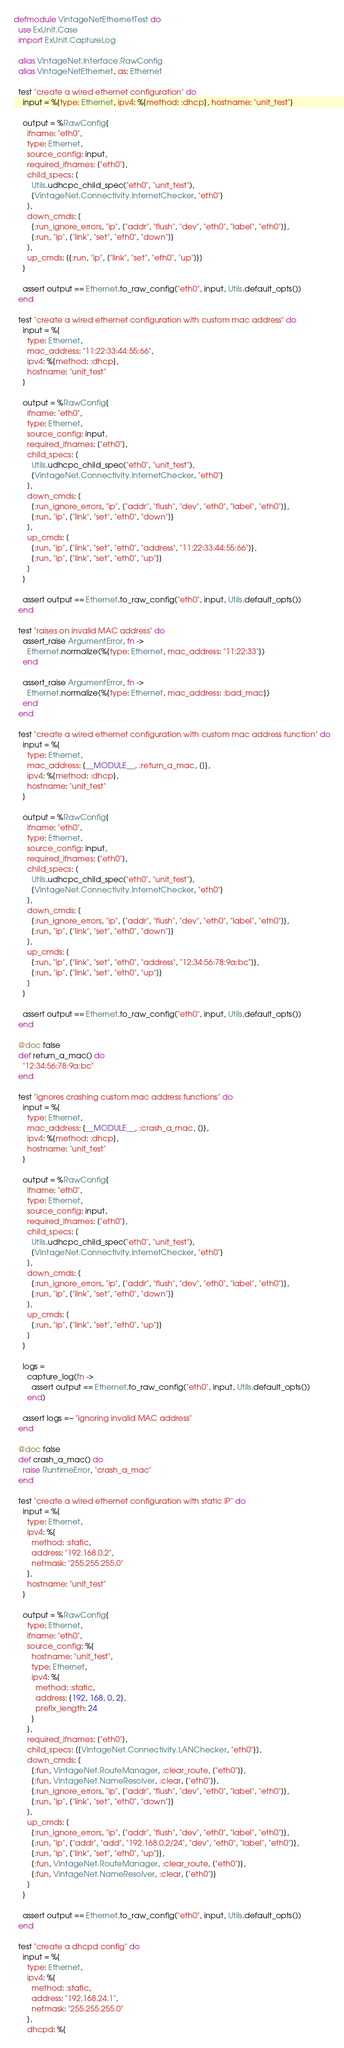<code> <loc_0><loc_0><loc_500><loc_500><_Elixir_>defmodule VintageNetEthernetTest do
  use ExUnit.Case
  import ExUnit.CaptureLog

  alias VintageNet.Interface.RawConfig
  alias VintageNetEthernet, as: Ethernet

  test "create a wired ethernet configuration" do
    input = %{type: Ethernet, ipv4: %{method: :dhcp}, hostname: "unit_test"}

    output = %RawConfig{
      ifname: "eth0",
      type: Ethernet,
      source_config: input,
      required_ifnames: ["eth0"],
      child_specs: [
        Utils.udhcpc_child_spec("eth0", "unit_test"),
        {VintageNet.Connectivity.InternetChecker, "eth0"}
      ],
      down_cmds: [
        {:run_ignore_errors, "ip", ["addr", "flush", "dev", "eth0", "label", "eth0"]},
        {:run, "ip", ["link", "set", "eth0", "down"]}
      ],
      up_cmds: [{:run, "ip", ["link", "set", "eth0", "up"]}]
    }

    assert output == Ethernet.to_raw_config("eth0", input, Utils.default_opts())
  end

  test "create a wired ethernet configuration with custom mac address" do
    input = %{
      type: Ethernet,
      mac_address: "11:22:33:44:55:66",
      ipv4: %{method: :dhcp},
      hostname: "unit_test"
    }

    output = %RawConfig{
      ifname: "eth0",
      type: Ethernet,
      source_config: input,
      required_ifnames: ["eth0"],
      child_specs: [
        Utils.udhcpc_child_spec("eth0", "unit_test"),
        {VintageNet.Connectivity.InternetChecker, "eth0"}
      ],
      down_cmds: [
        {:run_ignore_errors, "ip", ["addr", "flush", "dev", "eth0", "label", "eth0"]},
        {:run, "ip", ["link", "set", "eth0", "down"]}
      ],
      up_cmds: [
        {:run, "ip", ["link", "set", "eth0", "address", "11:22:33:44:55:66"]},
        {:run, "ip", ["link", "set", "eth0", "up"]}
      ]
    }

    assert output == Ethernet.to_raw_config("eth0", input, Utils.default_opts())
  end

  test "raises on invalid MAC address" do
    assert_raise ArgumentError, fn ->
      Ethernet.normalize(%{type: Ethernet, mac_address: "11:22:33"})
    end

    assert_raise ArgumentError, fn ->
      Ethernet.normalize(%{type: Ethernet, mac_address: :bad_mac})
    end
  end

  test "create a wired ethernet configuration with custom mac address function" do
    input = %{
      type: Ethernet,
      mac_address: {__MODULE__, :return_a_mac, []},
      ipv4: %{method: :dhcp},
      hostname: "unit_test"
    }

    output = %RawConfig{
      ifname: "eth0",
      type: Ethernet,
      source_config: input,
      required_ifnames: ["eth0"],
      child_specs: [
        Utils.udhcpc_child_spec("eth0", "unit_test"),
        {VintageNet.Connectivity.InternetChecker, "eth0"}
      ],
      down_cmds: [
        {:run_ignore_errors, "ip", ["addr", "flush", "dev", "eth0", "label", "eth0"]},
        {:run, "ip", ["link", "set", "eth0", "down"]}
      ],
      up_cmds: [
        {:run, "ip", ["link", "set", "eth0", "address", "12:34:56:78:9a:bc"]},
        {:run, "ip", ["link", "set", "eth0", "up"]}
      ]
    }

    assert output == Ethernet.to_raw_config("eth0", input, Utils.default_opts())
  end

  @doc false
  def return_a_mac() do
    "12:34:56:78:9a:bc"
  end

  test "ignores crashing custom mac address functions" do
    input = %{
      type: Ethernet,
      mac_address: {__MODULE__, :crash_a_mac, []},
      ipv4: %{method: :dhcp},
      hostname: "unit_test"
    }

    output = %RawConfig{
      ifname: "eth0",
      type: Ethernet,
      source_config: input,
      required_ifnames: ["eth0"],
      child_specs: [
        Utils.udhcpc_child_spec("eth0", "unit_test"),
        {VintageNet.Connectivity.InternetChecker, "eth0"}
      ],
      down_cmds: [
        {:run_ignore_errors, "ip", ["addr", "flush", "dev", "eth0", "label", "eth0"]},
        {:run, "ip", ["link", "set", "eth0", "down"]}
      ],
      up_cmds: [
        {:run, "ip", ["link", "set", "eth0", "up"]}
      ]
    }

    logs =
      capture_log(fn ->
        assert output == Ethernet.to_raw_config("eth0", input, Utils.default_opts())
      end)

    assert logs =~ "ignoring invalid MAC address"
  end

  @doc false
  def crash_a_mac() do
    raise RuntimeError, "crash_a_mac"
  end

  test "create a wired ethernet configuration with static IP" do
    input = %{
      type: Ethernet,
      ipv4: %{
        method: :static,
        address: "192.168.0.2",
        netmask: "255.255.255.0"
      },
      hostname: "unit_test"
    }

    output = %RawConfig{
      type: Ethernet,
      ifname: "eth0",
      source_config: %{
        hostname: "unit_test",
        type: Ethernet,
        ipv4: %{
          method: :static,
          address: {192, 168, 0, 2},
          prefix_length: 24
        }
      },
      required_ifnames: ["eth0"],
      child_specs: [{VintageNet.Connectivity.LANChecker, "eth0"}],
      down_cmds: [
        {:fun, VintageNet.RouteManager, :clear_route, ["eth0"]},
        {:fun, VintageNet.NameResolver, :clear, ["eth0"]},
        {:run_ignore_errors, "ip", ["addr", "flush", "dev", "eth0", "label", "eth0"]},
        {:run, "ip", ["link", "set", "eth0", "down"]}
      ],
      up_cmds: [
        {:run_ignore_errors, "ip", ["addr", "flush", "dev", "eth0", "label", "eth0"]},
        {:run, "ip", ["addr", "add", "192.168.0.2/24", "dev", "eth0", "label", "eth0"]},
        {:run, "ip", ["link", "set", "eth0", "up"]},
        {:fun, VintageNet.RouteManager, :clear_route, ["eth0"]},
        {:fun, VintageNet.NameResolver, :clear, ["eth0"]}
      ]
    }

    assert output == Ethernet.to_raw_config("eth0", input, Utils.default_opts())
  end

  test "create a dhcpd config" do
    input = %{
      type: Ethernet,
      ipv4: %{
        method: :static,
        address: "192.168.24.1",
        netmask: "255.255.255.0"
      },
      dhcpd: %{</code> 